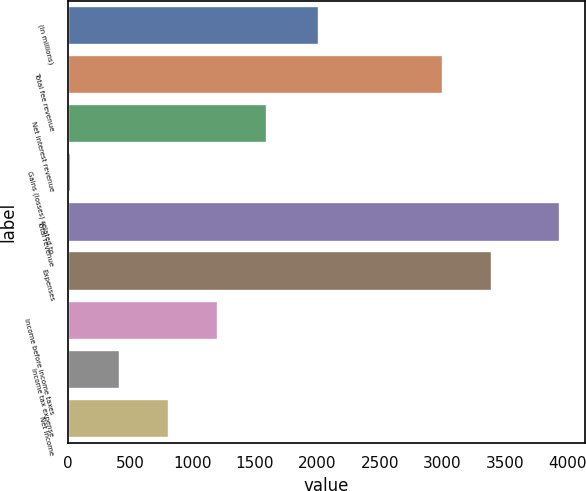<chart> <loc_0><loc_0><loc_500><loc_500><bar_chart><fcel>(In millions)<fcel>Total fee revenue<fcel>Net interest revenue<fcel>Gains (losses) related to<fcel>Total revenue<fcel>Expenses<fcel>Income before income taxes<fcel>Income tax expense<fcel>Net income<nl><fcel>2011<fcel>3004<fcel>1593<fcel>25<fcel>3945<fcel>3396<fcel>1201<fcel>417<fcel>809<nl></chart> 